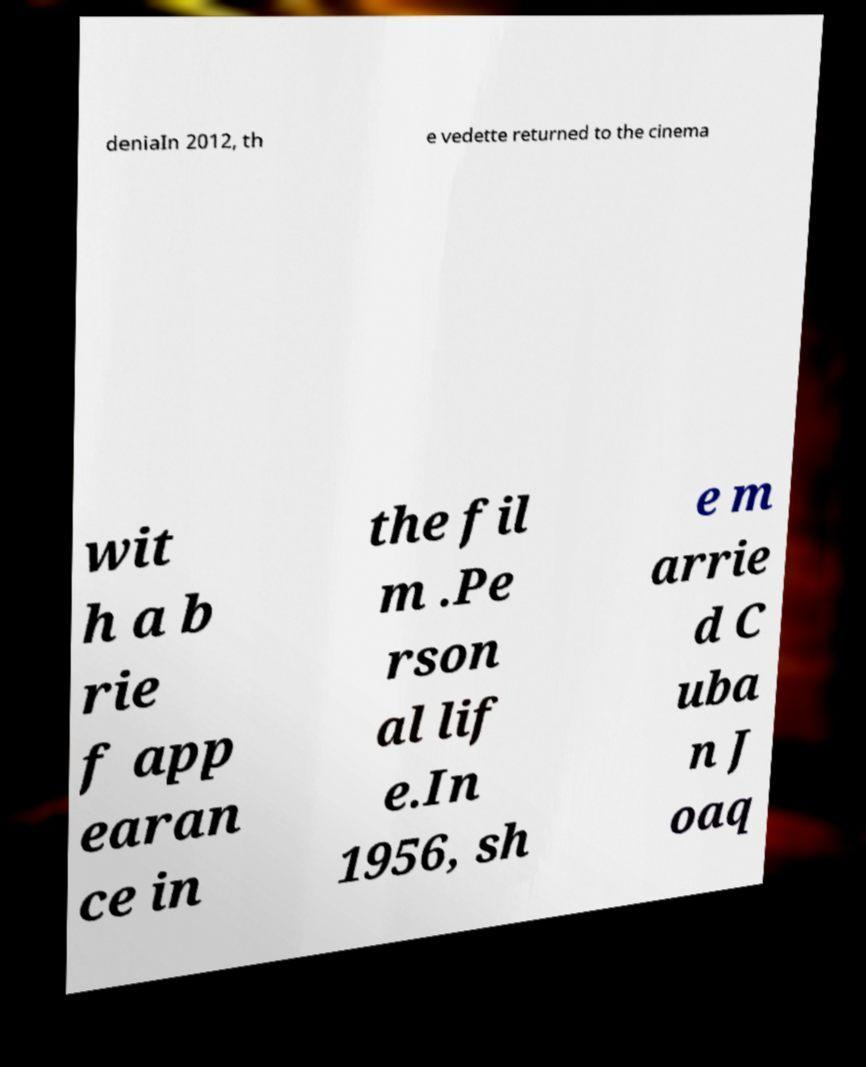I need the written content from this picture converted into text. Can you do that? deniaIn 2012, th e vedette returned to the cinema wit h a b rie f app earan ce in the fil m .Pe rson al lif e.In 1956, sh e m arrie d C uba n J oaq 